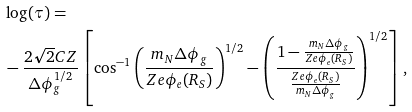Convert formula to latex. <formula><loc_0><loc_0><loc_500><loc_500>& \log ( \tau ) = \\ & - \frac { 2 \sqrt { 2 } C Z } { \Delta \phi _ { g } ^ { 1 / 2 } } \left [ \cos ^ { - 1 } { \left ( \frac { m _ { N } \Delta \phi _ { g } } { Z e \phi _ { e } ( R _ { S } ) } \right ) ^ { 1 / 2 } } - \left ( \frac { 1 - \frac { m _ { N } \Delta \phi _ { g } } { Z e \phi _ { e } ( R _ { S } ) } } { \frac { Z e \phi _ { e } ( R _ { S } ) } { m _ { N } \Delta \phi _ { g } } } \right ) ^ { 1 / 2 } \right ] ,</formula> 